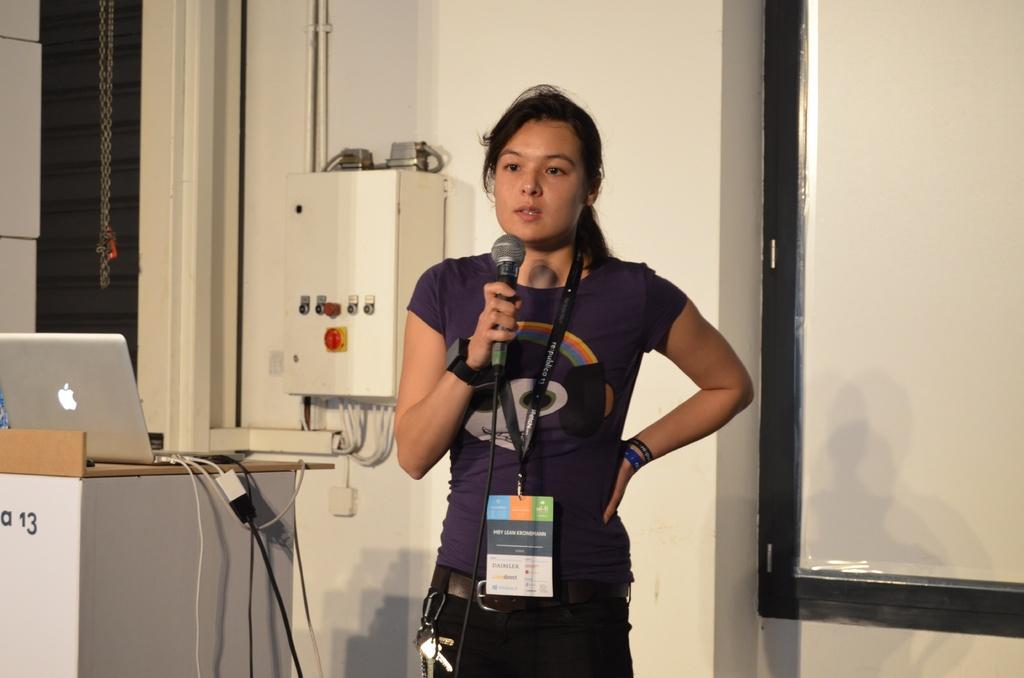Can you describe this image briefly? In this picture we can see woman holding mic in her hand and talking and beside to her we can see podium with laptop on it and at back of her we can see wall, box, pipe, screen. 